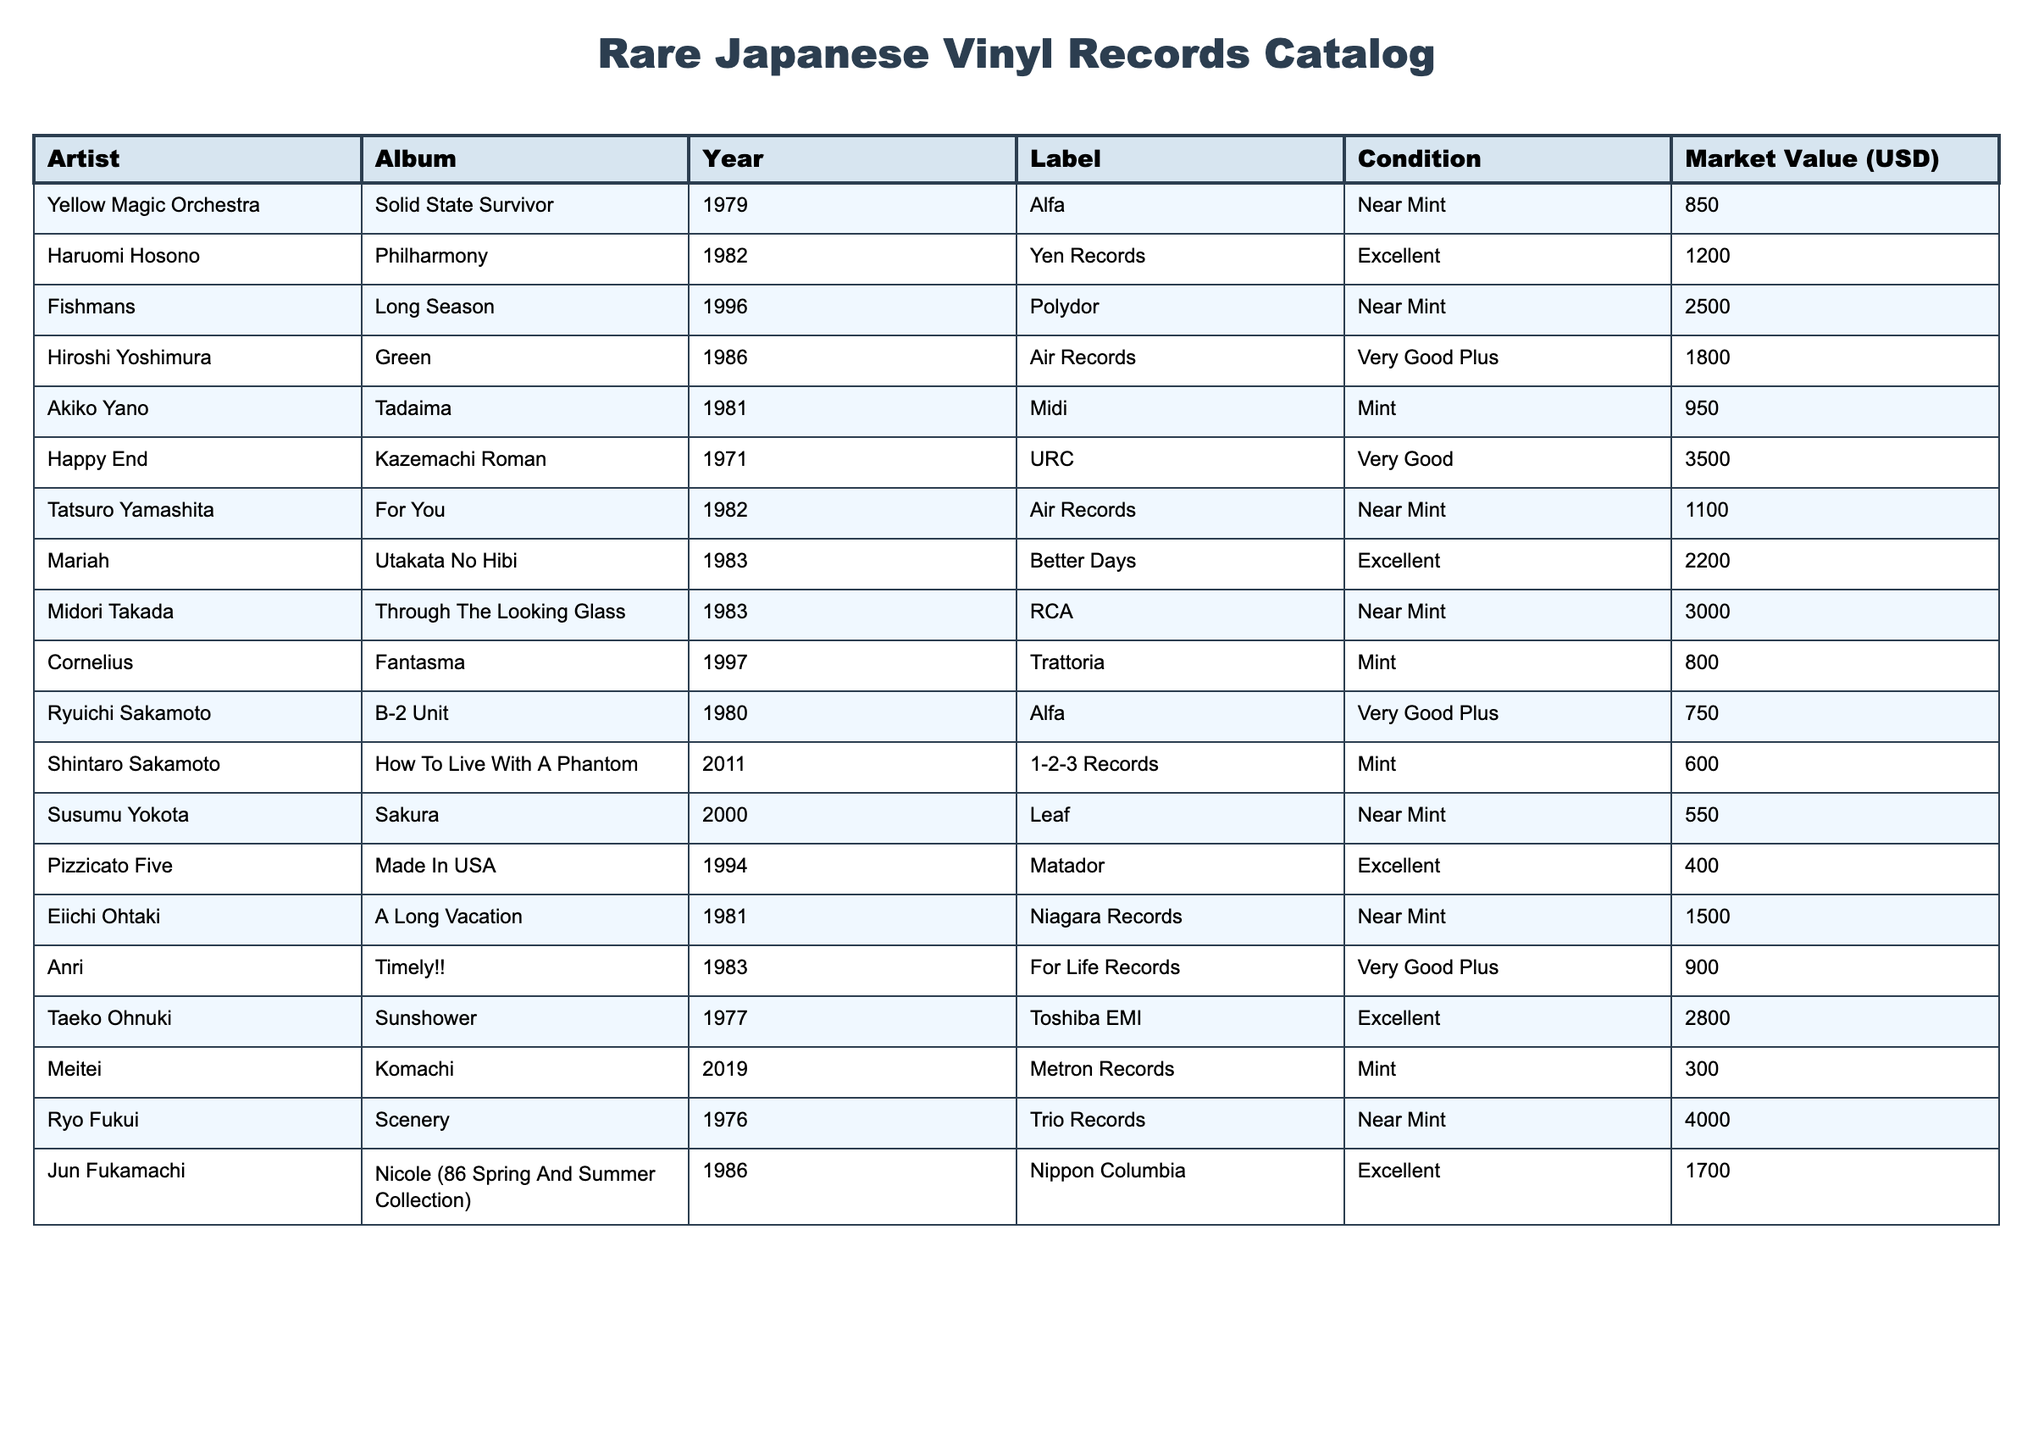What is the market value of the album "Solid State Survivor" by Yellow Magic Orchestra? The table lists the market value of "Solid State Survivor" under the "Market Value (USD)" column where the artist is Yellow Magic Orchestra. The listed value is 850.
Answer: 850 Which album has the highest market value and what is that value? By scanning the "Market Value (USD)" column, "Kazemachi Roman" by Happy End has the highest value of 3500.
Answer: 3500 What is the average market value of records released in the 1980s? The albums from the 1980s are "Solid State Survivor" (850), "Philharmony" (1200), "B-2 Unit" (750), "For You" (1100), "Tadaima" (950), "A Long Vacation" (1500), "Timely!!" (900), and "Sunshower" (2800). Adding these gives a total of 850+1200+750+1100+950+1500+900+2800 = 10550. There are 8 albums, so the average is 10550/8 = 1318.75.
Answer: 1318.75 Is "Utakata No Hibi" in Near Mint condition? The table shows that "Utakata No Hibi" is listed as being in Excellent condition, so the statement is false.
Answer: No How many albums have a market value greater than 2000? From the table, the albums with values greater than 2000 are "Long Season" (2500), "Utakata No Hibi" (2200), "Through The Looking Glass" (3000), "Kazemachi Roman" (3500), "Scenery" (4000), and "Sunshower" (2800). Counting these, there are 6 albums with a market value greater than 2000.
Answer: 6 Which artist has only one entry in this catalog and what is the album's market value? Scanning the table, "Shintaro Sakamoto" has only one entry with the album "How To Live With A Phantom" and its market value is 600.
Answer: 600 What is the difference in market value between "Ryo Fukui, Scenery" and "Happy End, Kazemachi Roman"? The market value of "Scenery" is 4000 and "Kazemachi Roman" is 3500. The difference is 4000 - 3500 = 500.
Answer: 500 Among the listed albums, which album from 1994 has the lowest market value? The album from 1994 is "Made In USA" by Pizzicato Five, and its market value is 400, which is the only value for that year, thus it is the lowest.
Answer: 400 How many artists appeared in this table with records in mint condition? The records in mint condition are by Akiko Yano, Midori Takada, and Shintaro Sakamoto, which means there are 3 artists with albums in mint condition.
Answer: 3 Is "Long Season" by Fishmans the only album listed under the Polydor label? The table only shows "Long Season" by Fishmans under Polydor, so the statement is true as no other album is listed with that label.
Answer: Yes 